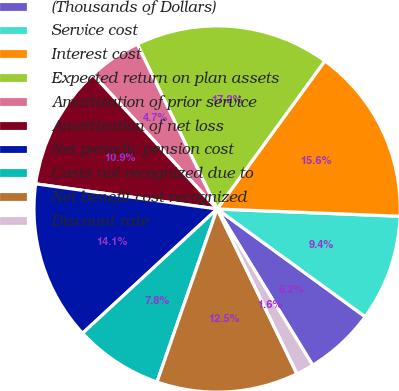<chart> <loc_0><loc_0><loc_500><loc_500><pie_chart><fcel>(Thousands of Dollars)<fcel>Service cost<fcel>Interest cost<fcel>Expected return on plan assets<fcel>Amortization of prior service<fcel>Amortization of net loss<fcel>Net periodic pension cost<fcel>Costs not recognized due to<fcel>Net benefit cost recognized<fcel>Discount rate<nl><fcel>6.25%<fcel>9.38%<fcel>15.62%<fcel>17.19%<fcel>4.69%<fcel>10.94%<fcel>14.06%<fcel>7.81%<fcel>12.5%<fcel>1.56%<nl></chart> 